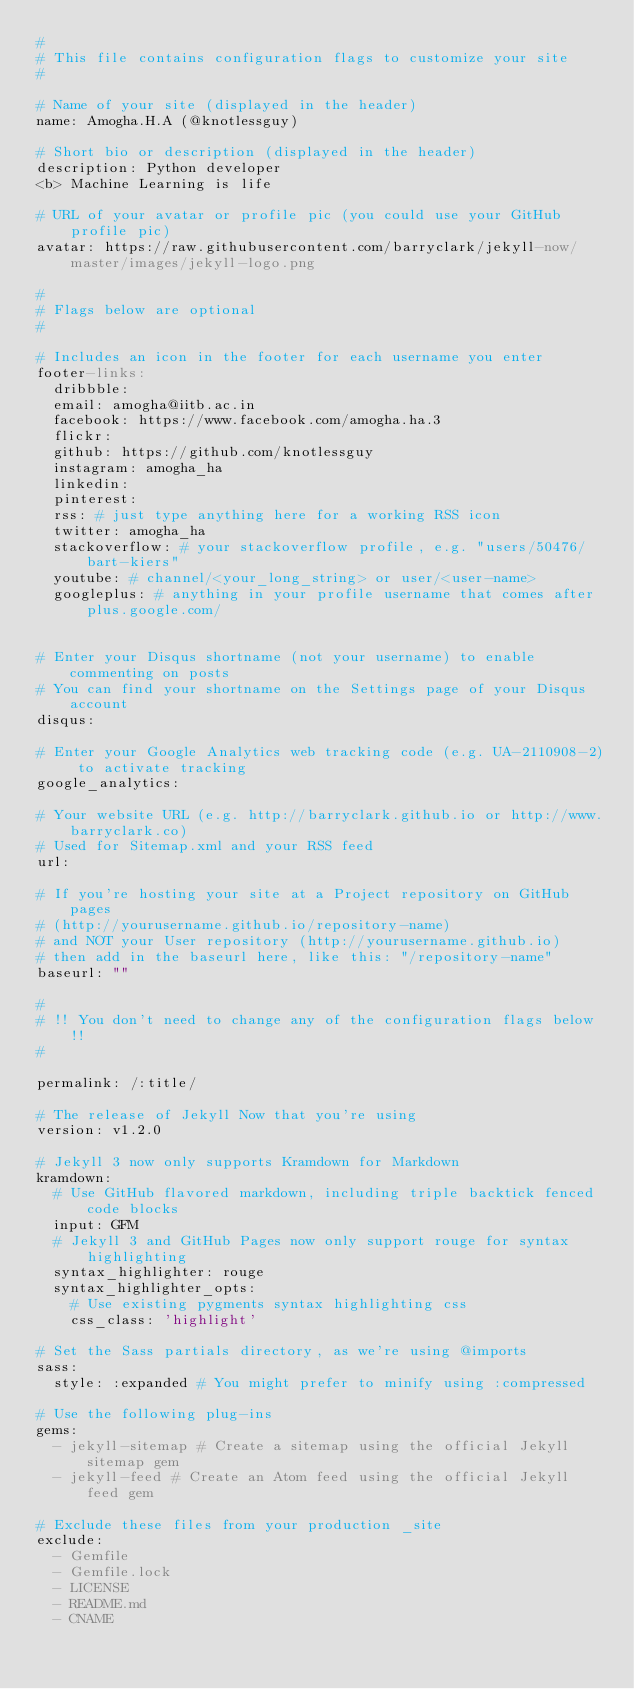<code> <loc_0><loc_0><loc_500><loc_500><_YAML_>#
# This file contains configuration flags to customize your site
#

# Name of your site (displayed in the header)
name: Amogha.H.A (@knotlessguy)

# Short bio or description (displayed in the header)
description: Python developer 
<b> Machine Learning is life

# URL of your avatar or profile pic (you could use your GitHub profile pic)
avatar: https://raw.githubusercontent.com/barryclark/jekyll-now/master/images/jekyll-logo.png

#
# Flags below are optional
#

# Includes an icon in the footer for each username you enter
footer-links:
  dribbble:
  email: amogha@iitb.ac.in
  facebook: https://www.facebook.com/amogha.ha.3
  flickr:
  github: https://github.com/knotlessguy
  instagram: amogha_ha
  linkedin:
  pinterest:
  rss: # just type anything here for a working RSS icon
  twitter: amogha_ha
  stackoverflow: # your stackoverflow profile, e.g. "users/50476/bart-kiers"
  youtube: # channel/<your_long_string> or user/<user-name>
  googleplus: # anything in your profile username that comes after plus.google.com/


# Enter your Disqus shortname (not your username) to enable commenting on posts
# You can find your shortname on the Settings page of your Disqus account
disqus:

# Enter your Google Analytics web tracking code (e.g. UA-2110908-2) to activate tracking
google_analytics:

# Your website URL (e.g. http://barryclark.github.io or http://www.barryclark.co)
# Used for Sitemap.xml and your RSS feed
url:

# If you're hosting your site at a Project repository on GitHub pages
# (http://yourusername.github.io/repository-name)
# and NOT your User repository (http://yourusername.github.io)
# then add in the baseurl here, like this: "/repository-name"
baseurl: ""

#
# !! You don't need to change any of the configuration flags below !!
#

permalink: /:title/

# The release of Jekyll Now that you're using
version: v1.2.0

# Jekyll 3 now only supports Kramdown for Markdown
kramdown:
  # Use GitHub flavored markdown, including triple backtick fenced code blocks
  input: GFM
  # Jekyll 3 and GitHub Pages now only support rouge for syntax highlighting
  syntax_highlighter: rouge
  syntax_highlighter_opts:
    # Use existing pygments syntax highlighting css
    css_class: 'highlight'

# Set the Sass partials directory, as we're using @imports
sass:
  style: :expanded # You might prefer to minify using :compressed

# Use the following plug-ins
gems:
  - jekyll-sitemap # Create a sitemap using the official Jekyll sitemap gem
  - jekyll-feed # Create an Atom feed using the official Jekyll feed gem

# Exclude these files from your production _site
exclude:
  - Gemfile
  - Gemfile.lock
  - LICENSE
  - README.md
  - CNAME
</code> 